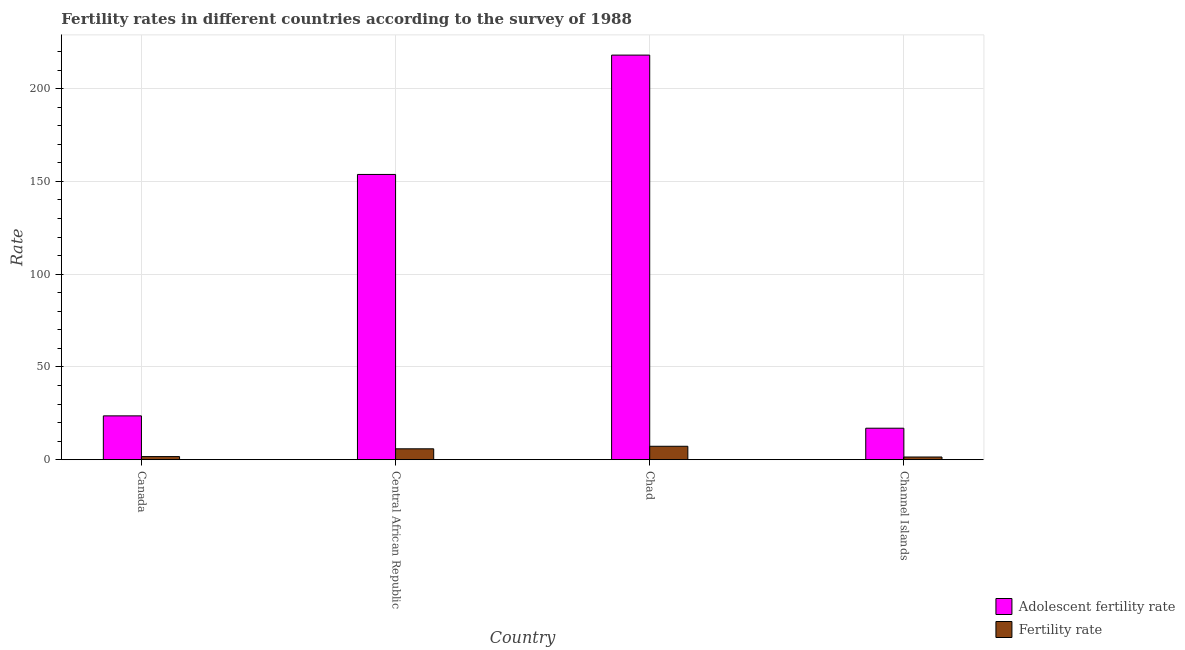How many groups of bars are there?
Offer a very short reply. 4. Are the number of bars per tick equal to the number of legend labels?
Your answer should be very brief. Yes. Are the number of bars on each tick of the X-axis equal?
Make the answer very short. Yes. How many bars are there on the 3rd tick from the right?
Give a very brief answer. 2. What is the label of the 2nd group of bars from the left?
Provide a succinct answer. Central African Republic. What is the fertility rate in Canada?
Your response must be concise. 1.68. Across all countries, what is the maximum fertility rate?
Your response must be concise. 7.24. Across all countries, what is the minimum fertility rate?
Provide a short and direct response. 1.45. In which country was the fertility rate maximum?
Ensure brevity in your answer.  Chad. In which country was the fertility rate minimum?
Your answer should be very brief. Channel Islands. What is the total adolescent fertility rate in the graph?
Make the answer very short. 412.44. What is the difference between the fertility rate in Central African Republic and that in Chad?
Offer a terse response. -1.37. What is the difference between the fertility rate in Canada and the adolescent fertility rate in Central African Republic?
Provide a succinct answer. -152.08. What is the average adolescent fertility rate per country?
Keep it short and to the point. 103.11. What is the difference between the fertility rate and adolescent fertility rate in Central African Republic?
Ensure brevity in your answer.  -147.89. In how many countries, is the adolescent fertility rate greater than 190 ?
Ensure brevity in your answer.  1. What is the ratio of the fertility rate in Canada to that in Channel Islands?
Give a very brief answer. 1.16. What is the difference between the highest and the second highest fertility rate?
Provide a succinct answer. 1.37. What is the difference between the highest and the lowest adolescent fertility rate?
Provide a short and direct response. 201.12. In how many countries, is the fertility rate greater than the average fertility rate taken over all countries?
Give a very brief answer. 2. What does the 2nd bar from the left in Canada represents?
Your response must be concise. Fertility rate. What does the 2nd bar from the right in Canada represents?
Offer a very short reply. Adolescent fertility rate. Are all the bars in the graph horizontal?
Give a very brief answer. No. How many countries are there in the graph?
Give a very brief answer. 4. Are the values on the major ticks of Y-axis written in scientific E-notation?
Make the answer very short. No. Does the graph contain grids?
Provide a short and direct response. Yes. How many legend labels are there?
Offer a very short reply. 2. How are the legend labels stacked?
Make the answer very short. Vertical. What is the title of the graph?
Give a very brief answer. Fertility rates in different countries according to the survey of 1988. Does "Male" appear as one of the legend labels in the graph?
Give a very brief answer. No. What is the label or title of the X-axis?
Give a very brief answer. Country. What is the label or title of the Y-axis?
Your response must be concise. Rate. What is the Rate of Adolescent fertility rate in Canada?
Provide a short and direct response. 23.62. What is the Rate of Fertility rate in Canada?
Ensure brevity in your answer.  1.68. What is the Rate of Adolescent fertility rate in Central African Republic?
Your response must be concise. 153.76. What is the Rate of Fertility rate in Central African Republic?
Keep it short and to the point. 5.87. What is the Rate of Adolescent fertility rate in Chad?
Offer a terse response. 218.09. What is the Rate of Fertility rate in Chad?
Offer a terse response. 7.24. What is the Rate in Adolescent fertility rate in Channel Islands?
Provide a short and direct response. 16.97. What is the Rate of Fertility rate in Channel Islands?
Give a very brief answer. 1.45. Across all countries, what is the maximum Rate of Adolescent fertility rate?
Your answer should be compact. 218.09. Across all countries, what is the maximum Rate in Fertility rate?
Provide a succinct answer. 7.24. Across all countries, what is the minimum Rate in Adolescent fertility rate?
Give a very brief answer. 16.97. Across all countries, what is the minimum Rate in Fertility rate?
Ensure brevity in your answer.  1.45. What is the total Rate of Adolescent fertility rate in the graph?
Offer a terse response. 412.44. What is the total Rate of Fertility rate in the graph?
Offer a terse response. 16.24. What is the difference between the Rate in Adolescent fertility rate in Canada and that in Central African Republic?
Keep it short and to the point. -130.14. What is the difference between the Rate in Fertility rate in Canada and that in Central African Republic?
Provide a short and direct response. -4.19. What is the difference between the Rate in Adolescent fertility rate in Canada and that in Chad?
Offer a terse response. -194.47. What is the difference between the Rate of Fertility rate in Canada and that in Chad?
Your answer should be very brief. -5.56. What is the difference between the Rate in Adolescent fertility rate in Canada and that in Channel Islands?
Provide a succinct answer. 6.65. What is the difference between the Rate in Fertility rate in Canada and that in Channel Islands?
Your answer should be compact. 0.23. What is the difference between the Rate in Adolescent fertility rate in Central African Republic and that in Chad?
Your answer should be compact. -64.33. What is the difference between the Rate in Fertility rate in Central African Republic and that in Chad?
Keep it short and to the point. -1.37. What is the difference between the Rate of Adolescent fertility rate in Central African Republic and that in Channel Islands?
Offer a terse response. 136.79. What is the difference between the Rate of Fertility rate in Central African Republic and that in Channel Islands?
Offer a terse response. 4.42. What is the difference between the Rate of Adolescent fertility rate in Chad and that in Channel Islands?
Offer a terse response. 201.12. What is the difference between the Rate of Fertility rate in Chad and that in Channel Islands?
Provide a short and direct response. 5.79. What is the difference between the Rate of Adolescent fertility rate in Canada and the Rate of Fertility rate in Central African Republic?
Give a very brief answer. 17.76. What is the difference between the Rate in Adolescent fertility rate in Canada and the Rate in Fertility rate in Chad?
Keep it short and to the point. 16.39. What is the difference between the Rate in Adolescent fertility rate in Canada and the Rate in Fertility rate in Channel Islands?
Make the answer very short. 22.17. What is the difference between the Rate of Adolescent fertility rate in Central African Republic and the Rate of Fertility rate in Chad?
Your response must be concise. 146.52. What is the difference between the Rate of Adolescent fertility rate in Central African Republic and the Rate of Fertility rate in Channel Islands?
Give a very brief answer. 152.31. What is the difference between the Rate of Adolescent fertility rate in Chad and the Rate of Fertility rate in Channel Islands?
Offer a terse response. 216.64. What is the average Rate in Adolescent fertility rate per country?
Offer a terse response. 103.11. What is the average Rate of Fertility rate per country?
Ensure brevity in your answer.  4.06. What is the difference between the Rate of Adolescent fertility rate and Rate of Fertility rate in Canada?
Provide a short and direct response. 21.94. What is the difference between the Rate in Adolescent fertility rate and Rate in Fertility rate in Central African Republic?
Offer a very short reply. 147.89. What is the difference between the Rate of Adolescent fertility rate and Rate of Fertility rate in Chad?
Your answer should be very brief. 210.85. What is the difference between the Rate of Adolescent fertility rate and Rate of Fertility rate in Channel Islands?
Provide a short and direct response. 15.52. What is the ratio of the Rate in Adolescent fertility rate in Canada to that in Central African Republic?
Your answer should be very brief. 0.15. What is the ratio of the Rate of Fertility rate in Canada to that in Central African Republic?
Give a very brief answer. 0.29. What is the ratio of the Rate of Adolescent fertility rate in Canada to that in Chad?
Keep it short and to the point. 0.11. What is the ratio of the Rate of Fertility rate in Canada to that in Chad?
Keep it short and to the point. 0.23. What is the ratio of the Rate in Adolescent fertility rate in Canada to that in Channel Islands?
Your response must be concise. 1.39. What is the ratio of the Rate of Fertility rate in Canada to that in Channel Islands?
Offer a very short reply. 1.16. What is the ratio of the Rate of Adolescent fertility rate in Central African Republic to that in Chad?
Provide a succinct answer. 0.7. What is the ratio of the Rate in Fertility rate in Central African Republic to that in Chad?
Keep it short and to the point. 0.81. What is the ratio of the Rate of Adolescent fertility rate in Central African Republic to that in Channel Islands?
Keep it short and to the point. 9.06. What is the ratio of the Rate of Fertility rate in Central African Republic to that in Channel Islands?
Keep it short and to the point. 4.04. What is the ratio of the Rate in Adolescent fertility rate in Chad to that in Channel Islands?
Give a very brief answer. 12.85. What is the ratio of the Rate in Fertility rate in Chad to that in Channel Islands?
Your answer should be very brief. 4.98. What is the difference between the highest and the second highest Rate in Adolescent fertility rate?
Offer a terse response. 64.33. What is the difference between the highest and the second highest Rate of Fertility rate?
Provide a succinct answer. 1.37. What is the difference between the highest and the lowest Rate of Adolescent fertility rate?
Your answer should be compact. 201.12. What is the difference between the highest and the lowest Rate of Fertility rate?
Your response must be concise. 5.79. 